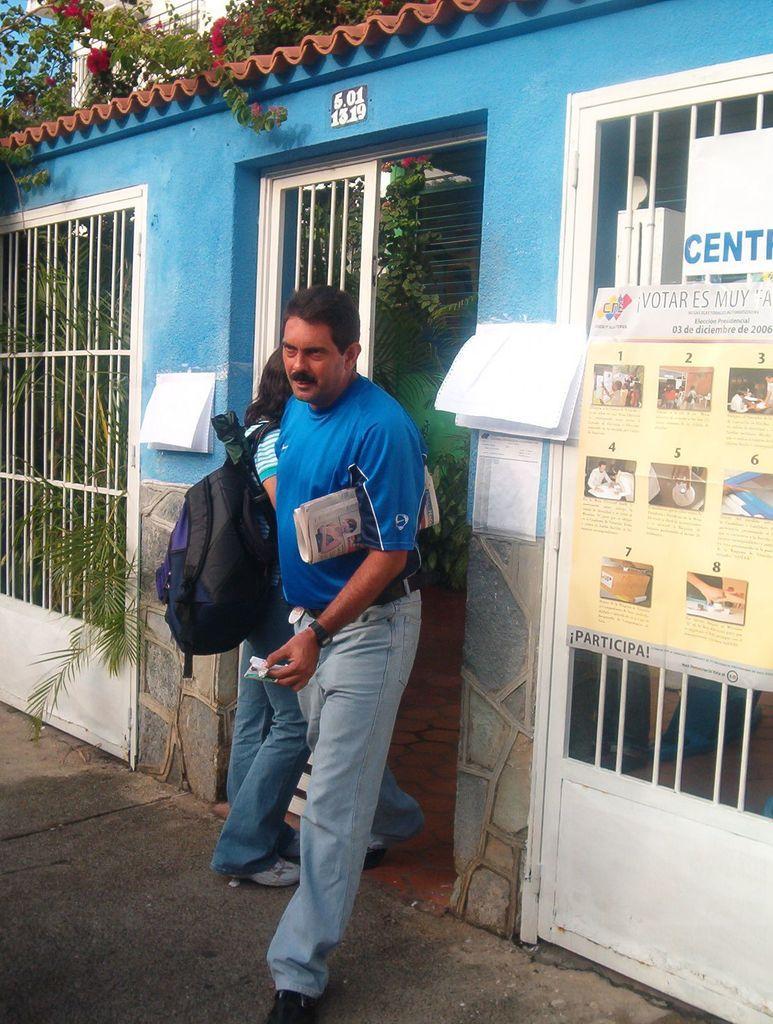Please provide a concise description of this image. In this picture there is a man holding the paper and he is walking and there is a woman walking. At the back there is a building and there are boards and papers on the wall and there is text on the board. There are trees behind the wall. At the top there is sky and there are roof tiles on the building. At the bottom there is a road. 